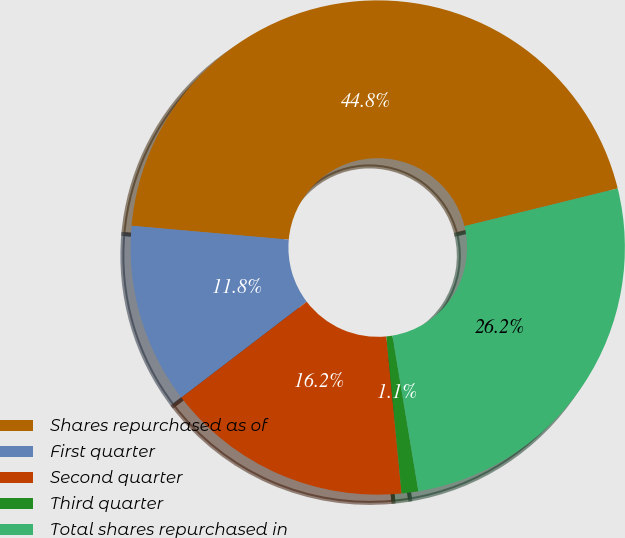Convert chart. <chart><loc_0><loc_0><loc_500><loc_500><pie_chart><fcel>Shares repurchased as of<fcel>First quarter<fcel>Second quarter<fcel>Third quarter<fcel>Total shares repurchased in<nl><fcel>44.76%<fcel>11.79%<fcel>16.15%<fcel>1.09%<fcel>26.21%<nl></chart> 